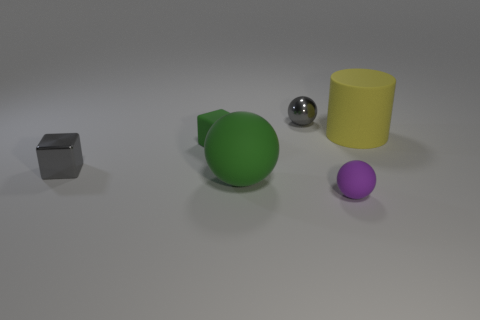There is a large rubber thing that is the same color as the small rubber block; what shape is it?
Give a very brief answer. Sphere. What material is the small sphere in front of the big yellow rubber object?
Give a very brief answer. Rubber. Are there any other things that are the same color as the rubber cube?
Give a very brief answer. Yes. Is the color of the small metallic block the same as the small metallic ball?
Offer a very short reply. Yes. Are there more big green matte balls to the right of the cylinder than gray metal cubes?
Make the answer very short. No. What number of other objects are the same material as the large ball?
Offer a very short reply. 3. What number of tiny objects are rubber things or rubber spheres?
Give a very brief answer. 2. Does the large cylinder have the same material as the tiny gray cube?
Ensure brevity in your answer.  No. How many small rubber objects are in front of the block on the right side of the tiny gray cube?
Offer a very short reply. 1. Are there any gray metallic objects that have the same shape as the tiny green matte object?
Provide a short and direct response. Yes. 